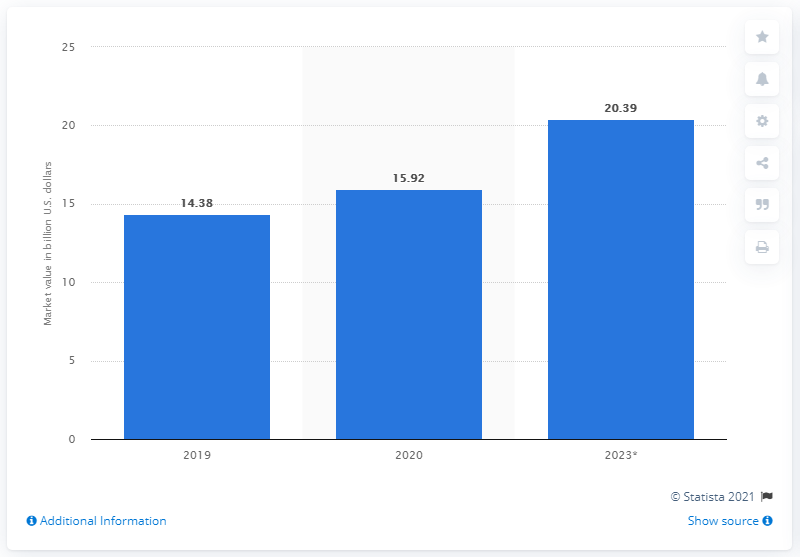Highlight a few significant elements in this photo. In 2020, the market value of organic meat in the United States was estimated to be 15.92 billion dollars. 